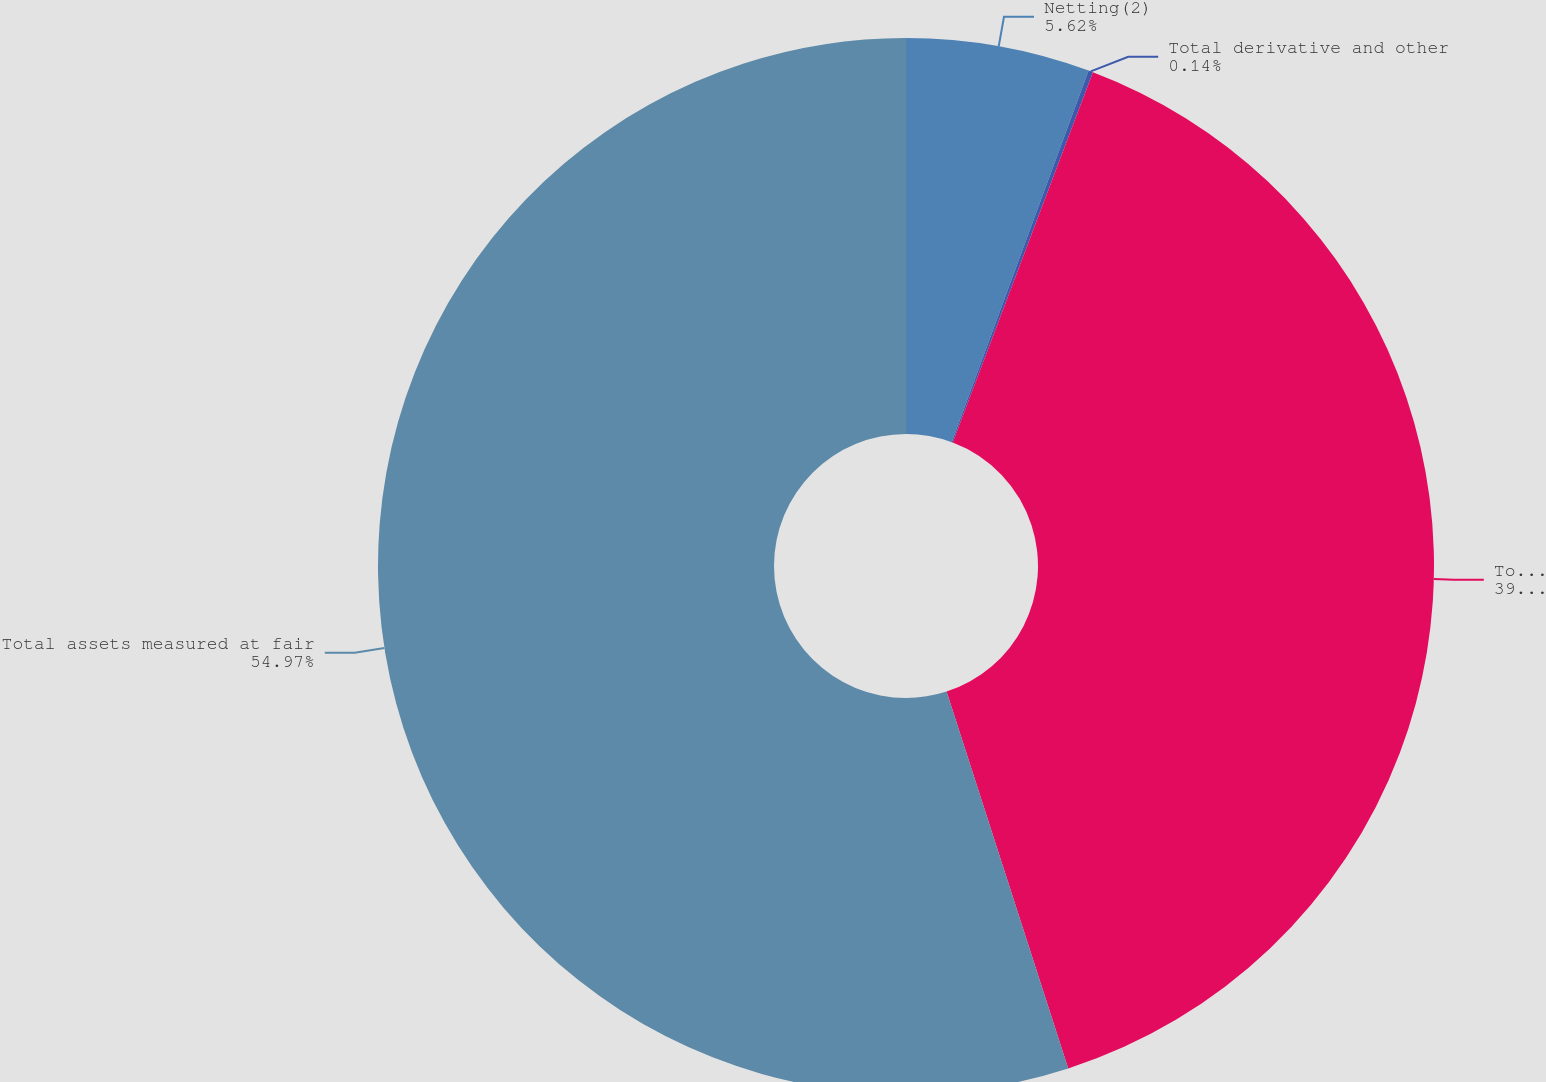Convert chart. <chart><loc_0><loc_0><loc_500><loc_500><pie_chart><fcel>Netting(2)<fcel>Total derivative and other<fcel>Total trading assets<fcel>Total assets measured at fair<nl><fcel>5.62%<fcel>0.14%<fcel>39.27%<fcel>54.97%<nl></chart> 